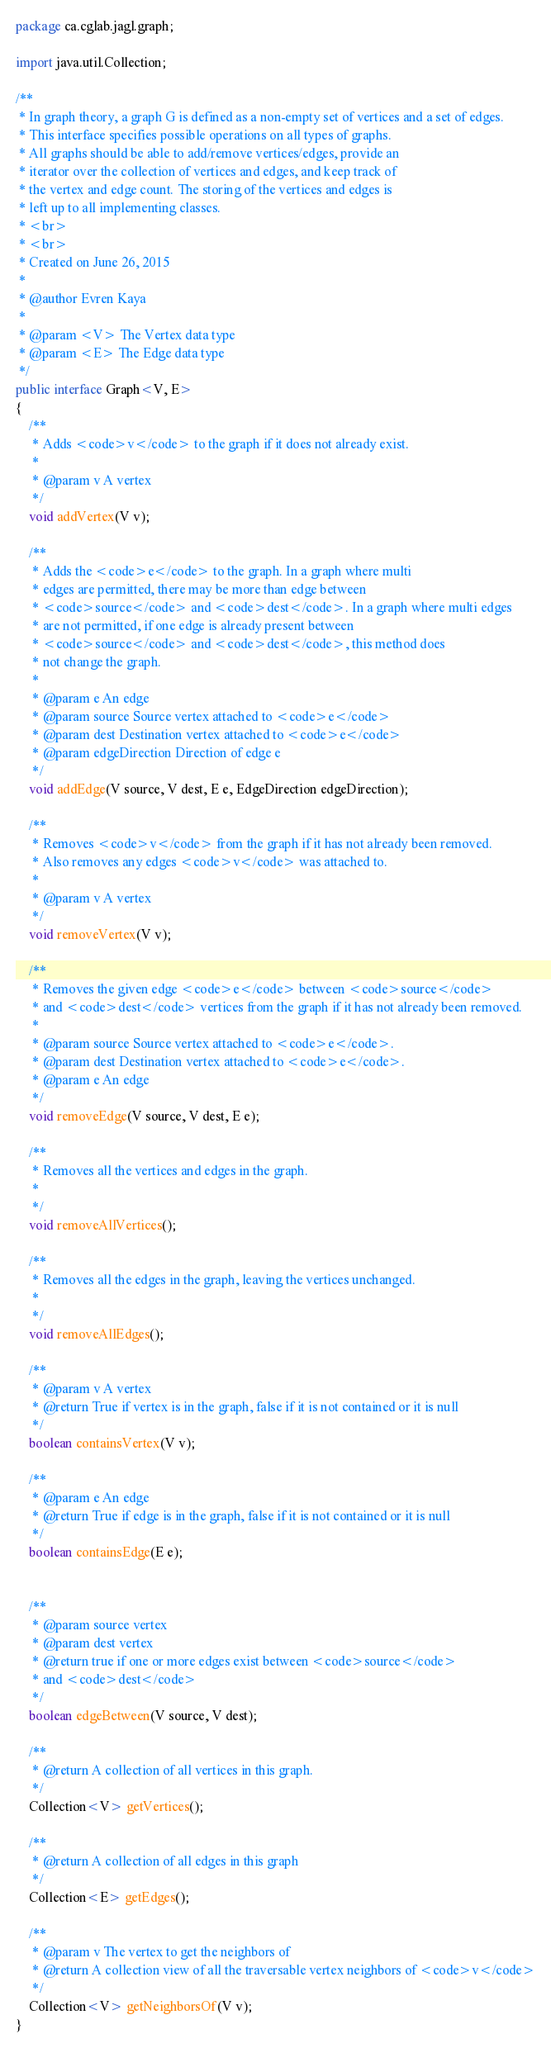<code> <loc_0><loc_0><loc_500><loc_500><_Java_>package ca.cglab.jagl.graph;

import java.util.Collection;

/**
 * In graph theory, a graph G is defined as a non-empty set of vertices and a set of edges.
 * This interface specifies possible operations on all types of graphs.
 * All graphs should be able to add/remove vertices/edges, provide an
 * iterator over the collection of vertices and edges, and keep track of
 * the vertex and edge count. The storing of the vertices and edges is
 * left up to all implementing classes.
 * <br>
 * <br>
 * Created on June 26, 2015
 * 
 * @author Evren Kaya
 * 
 * @param <V> The Vertex data type
 * @param <E> The Edge data type
 */
public interface Graph<V, E>
{
	/**
	 * Adds <code>v</code> to the graph if it does not already exist.
	 * 
	 * @param v A vertex
	 */
	void addVertex(V v);
	
	/**
	 * Adds the <code>e</code> to the graph. In a graph where multi 
	 * edges are permitted, there may be more than edge between 
	 * <code>source</code> and <code>dest</code>. In a graph where multi edges
	 * are not permitted, if one edge is already present between
	 * <code>source</code> and <code>dest</code>, this method does
	 * not change the graph.
	 * 
	 * @param e An edge
	 * @param source Source vertex attached to <code>e</code>
	 * @param dest Destination vertex attached to <code>e</code>
	 * @param edgeDirection Direction of edge e
	 */
	void addEdge(V source, V dest, E e, EdgeDirection edgeDirection);
	
	/**
	 * Removes <code>v</code> from the graph if it has not already been removed.
	 * Also removes any edges <code>v</code> was attached to.
	 * 
	 * @param v A vertex
	 */
	void removeVertex(V v);
	
	/**
	 * Removes the given edge <code>e</code> between <code>source</code>
	 * and <code>dest</code> vertices from the graph if it has not already been removed.
	 * 
	 * @param source Source vertex attached to <code>e</code>.
	 * @param dest Destination vertex attached to <code>e</code>.
	 * @param e An edge
	 */
	void removeEdge(V source, V dest, E e);
	
	/**
	 * Removes all the vertices and edges in the graph.
	 * 
	 */
	void removeAllVertices();
	
	/**
	 * Removes all the edges in the graph, leaving the vertices unchanged.
	 * 
	 */
	void removeAllEdges();
	
	/**
	 * @param v A vertex
	 * @return True if vertex is in the graph, false if it is not contained or it is null
	 */
	boolean containsVertex(V v);
	
	/**
	 * @param e An edge
	 * @return True if edge is in the graph, false if it is not contained or it is null
	 */
	boolean containsEdge(E e);
	
	
	/**
	 * @param source vertex
	 * @param dest vertex
	 * @return true if one or more edges exist between <code>source</code>
	 * and <code>dest</code>
	 */
	boolean edgeBetween(V source, V dest);
	
	/**
	 * @return A collection of all vertices in this graph.
	 */
	Collection<V> getVertices();
	
	/**
	 * @return A collection of all edges in this graph
	 */
	Collection<E> getEdges();
	
	/**
	 * @param v The vertex to get the neighbors of
	 * @return A collection view of all the traversable vertex neighbors of <code>v</code>
	 */
	Collection<V> getNeighborsOf(V v);
}
</code> 